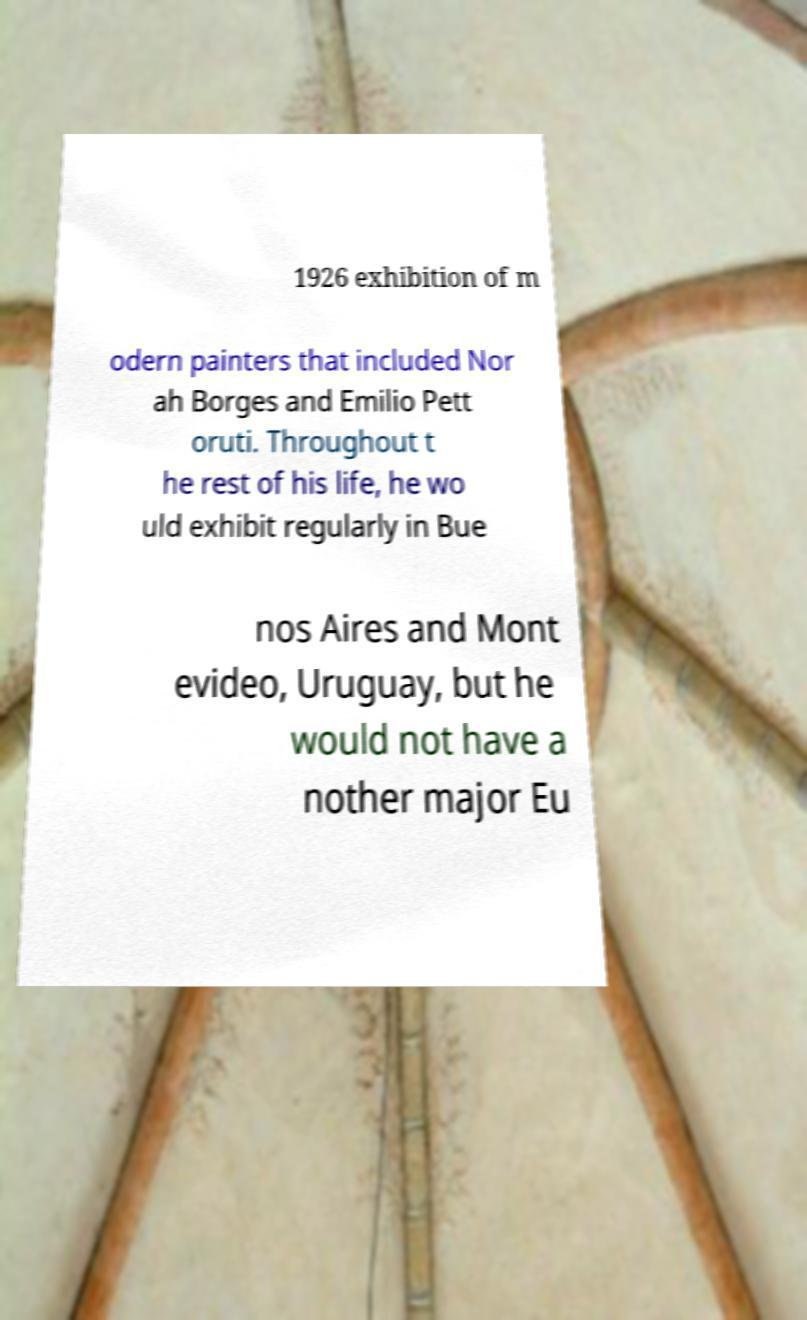What messages or text are displayed in this image? I need them in a readable, typed format. 1926 exhibition of m odern painters that included Nor ah Borges and Emilio Pett oruti. Throughout t he rest of his life, he wo uld exhibit regularly in Bue nos Aires and Mont evideo, Uruguay, but he would not have a nother major Eu 